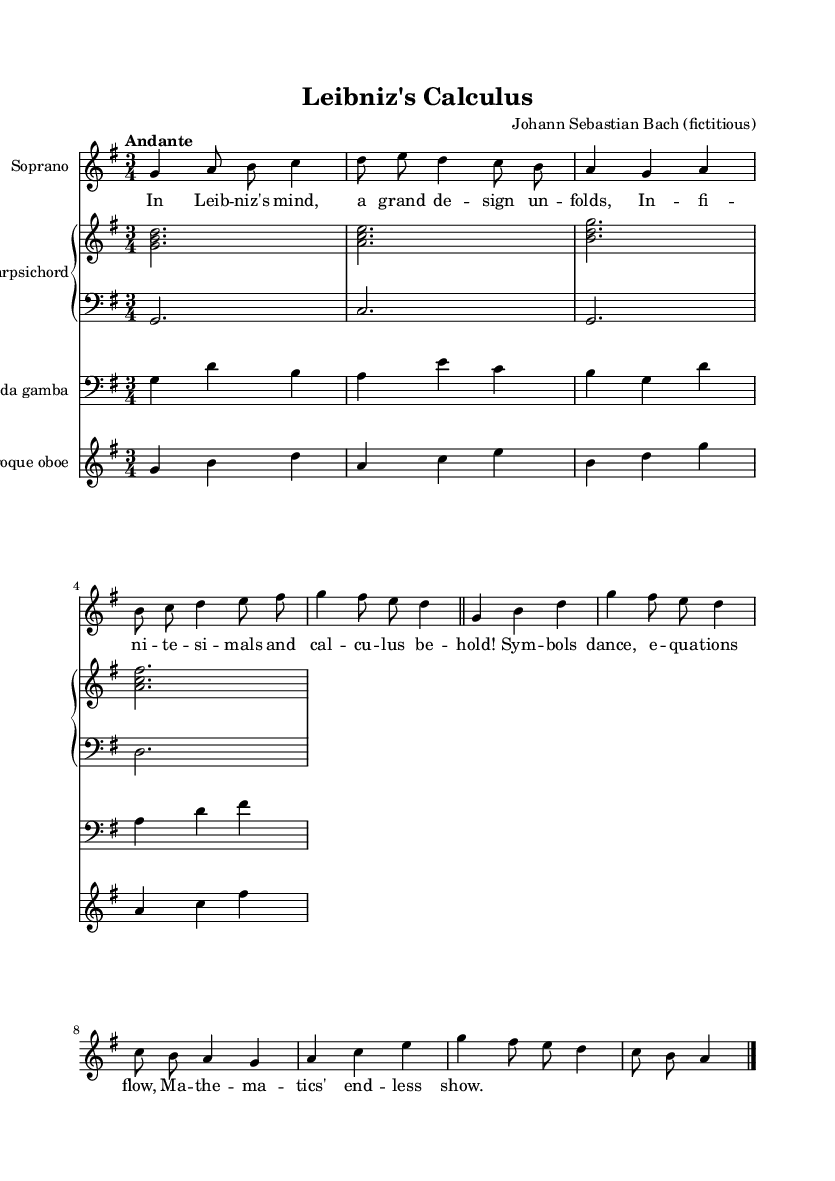What is the key signature of this music? The key signature is G major, which has one sharp (F#). This can be identified by looking at the beginning of the staff, where the sharp is noted.
Answer: G major What is the time signature of the piece? The time signature is 3/4, indicated at the beginning, which shows there are three beats per measure and the quarter note gets one beat.
Answer: 3/4 What is the tempo marking for this piece? The tempo marking is "Andante," which signifies a moderately slow tempo. This is specified at the beginning of the score.
Answer: Andante How many measures are in the soprano part? The soprano part consists of 6 measures, which are counted from the beginning to the bar line at the end. Each section of music is demarcated by a bar line.
Answer: 6 Who is the fictional composer of this piece? The fictional composer listed for this piece is Johann Sebastian Bach, as indicated in the header of the score.
Answer: Johann Sebastian Bach What instruments are included in the score? The score includes Soprano, Harpsichord, Viola da gamba, and Baroque oboe. This is evident from the different staves labeled for each instrument in the score.
Answer: Soprano, Harpsichord, Viola da gamba, Baroque oboe 